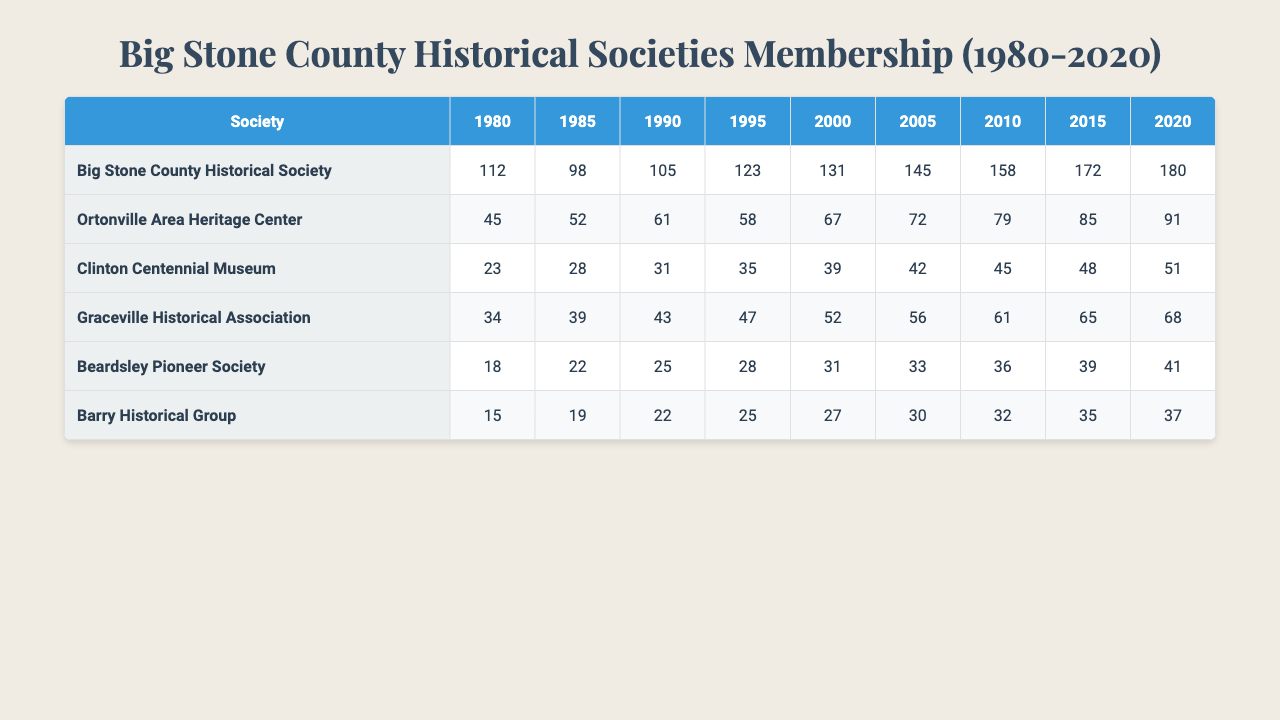What was the membership count for the Big Stone County Historical Society in 2000? In the table, locate the row for "Big Stone County Historical Society" and find the column for the year 2000. The membership count is 131.
Answer: 131 Which historical society had the highest membership in 2015? By checking the memberships listed for each society in the year 2015, the "Big Stone County Historical Society" has a membership of 172, which is the highest.
Answer: Big Stone County Historical Society Did the membership of the Clinton Centennial Museum increase every year from 1980 to 2020? Review the membership figures in the table for the Clinton Centennial Museum. The values are: 23, 28, 31, 35, 39, 42, 45, 48, 51. Each value is greater than the previous one, indicating consistent growth.
Answer: Yes What was the average membership for the Ortonville Area Heritage Center over the years? To find the average, sum the membership values for the Ortonville Area Heritage Center: (45 + 52 + 61 + 58 + 67 + 72 + 79 + 85 + 91) = 510. Then, divide by the number of years (9): 510 / 9 = 56.67. The average membership is approximately 56.67.
Answer: 56.67 How many more members did the Graceville Historical Association have in 2010 compared to 2000? Find the membership for Graceville Historical Association in 2010 (61) and 2000 (52). Subtract the 2000 figure from the 2010 figure: 61 - 52 = 9. Therefore, there were 9 more members in 2010.
Answer: 9 Was the membership of the Beardsley Pioneer Society never above 40 during the years recorded? Review the membership values for the Beardsley Pioneer Society across all years: 18, 22, 25, 28, 31, 33, 36, 39, 41. The highest recorded is 41, which means it was above 40 in 2020.
Answer: No What is the difference in membership between the Barry Historical Group and the Clinton Centennial Museum in 1995? Look at the years in the table for both societies. For 1995, the Barry Historical Group has 25 members, and the Clinton Centennial Museum has 35 members. The difference is 35 - 25 = 10.
Answer: 10 Which society had the smallest membership at the end of the observed period (2020)? Check the last column for the year 2020 in each society's row. The memberships are as follows: Big Stone County Historical Society (180), Ortonville Area Heritage Center (91), Clinton Centennial Museum (51), Graceville Historical Association (68), Beardsley Pioneer Society (41), and Barry Historical Group (37). The smallest is 37 for the Barry Historical Group.
Answer: Barry Historical Group How many societies had membership counts greater than 100 in 2010? Assess the memberships for 2010: Big Stone County Historical Society (158), Ortonville Area Heritage Center (79), Clinton Centennial Museum (45), Graceville Historical Association (61), Beardsley Pioneer Society (36), and Barry Historical Group (32). Only the Big Stone County Historical Society had more than 100 members, totaling 1 society.
Answer: 1 What year did the Graceville Historical Association first exceed 60 members? Checking the membership figures for the Graceville Historical Association, they are: 34, 39, 43, 47, 52, 56, 61, 65, 68. The first year exceeding 60 members is 2010, when membership was 61.
Answer: 2010 